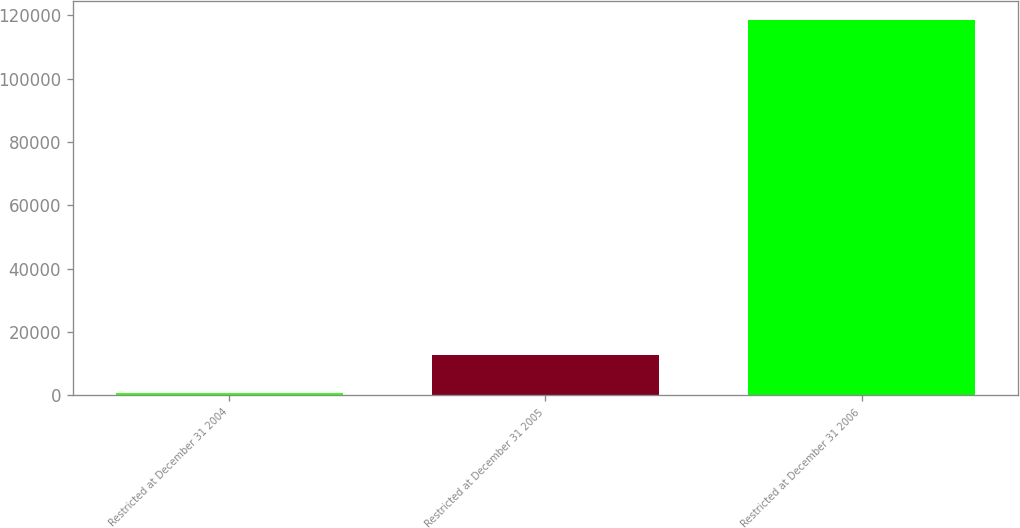Convert chart to OTSL. <chart><loc_0><loc_0><loc_500><loc_500><bar_chart><fcel>Restricted at December 31 2004<fcel>Restricted at December 31 2005<fcel>Restricted at December 31 2006<nl><fcel>844<fcel>12619.8<fcel>118602<nl></chart> 